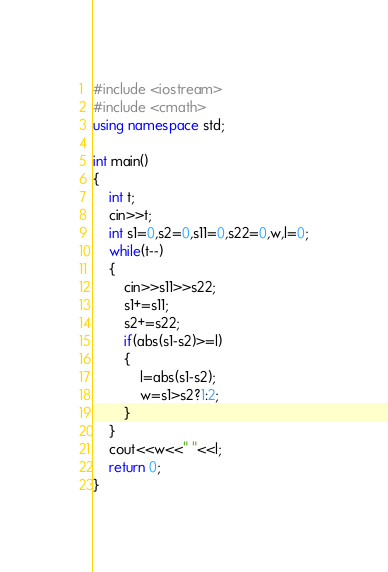<code> <loc_0><loc_0><loc_500><loc_500><_C++_>#include <iostream>
#include <cmath>
using namespace std;

int main()
{
    int t;
    cin>>t;
    int s1=0,s2=0,s11=0,s22=0,w,l=0;
    while(t--)
    {
        cin>>s11>>s22;
        s1+=s11;
        s2+=s22;
        if(abs(s1-s2)>=l)
        {
            l=abs(s1-s2);
            w=s1>s2?1:2;
        }
    }
    cout<<w<<" "<<l;
    return 0;
}
</code> 